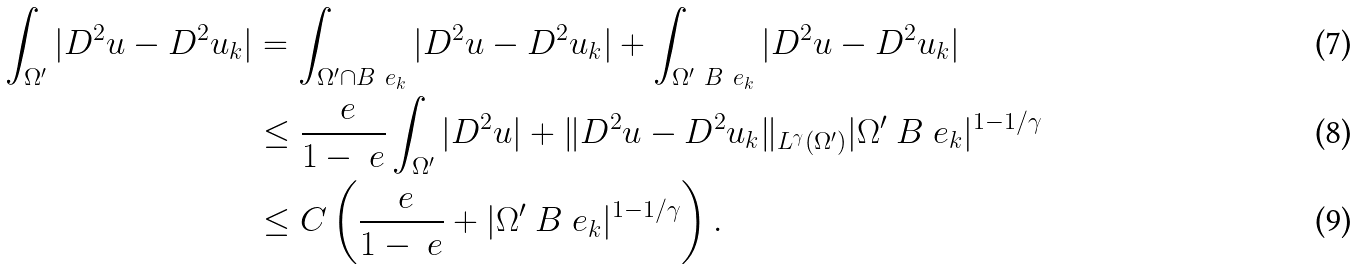Convert formula to latex. <formula><loc_0><loc_0><loc_500><loc_500>\int _ { \Omega ^ { \prime } } | D ^ { 2 } u - D ^ { 2 } u _ { k } | & = \int _ { \Omega ^ { \prime } \cap B ^ { \ } e _ { k } } | D ^ { 2 } u - D ^ { 2 } u _ { k } | + \int _ { \Omega ^ { \prime } \ B ^ { \ } e _ { k } } | D ^ { 2 } u - D ^ { 2 } u _ { k } | \\ & \leq \frac { \ e } { 1 - \ e } \int _ { \Omega ^ { \prime } } | D ^ { 2 } u | + \| D ^ { 2 } u - D ^ { 2 } u _ { k } \| _ { L ^ { \gamma } ( \Omega ^ { \prime } ) } | \Omega ^ { \prime } \ B ^ { \ } e _ { k } | ^ { 1 - 1 / \gamma } \\ & \leq C \left ( \frac { \ e } { 1 - \ e } + | \Omega ^ { \prime } \ B ^ { \ } e _ { k } | ^ { 1 - 1 / \gamma } \right ) .</formula> 